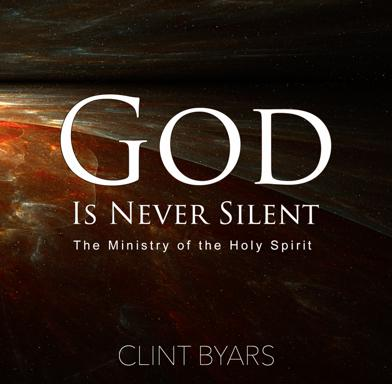What inspired the author to write 'God Is Never Silent: The Ministry of the Holy Spirit'? Although specific inspirations aren't detailed in the image, it's reasonable to assume that Clint Byars was motivated by a profound experience or realization about the active role of the Holy Spirit in everyday life. His writings likely stem from personal testimonies or theological insights that highlight the continuous dialogue between God and believers through the Holy Spirit. 